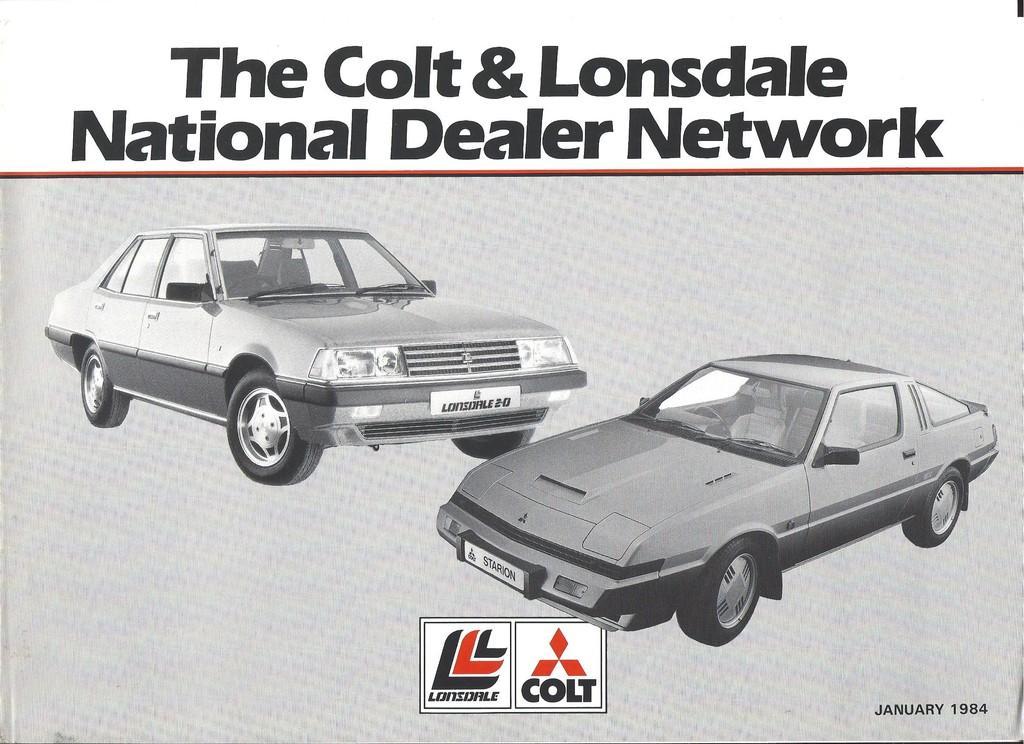Can you describe this image briefly? In this image I can see the paper. On the paper I can see the vehicles and something is written. 